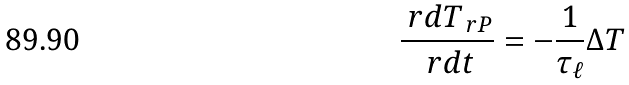<formula> <loc_0><loc_0><loc_500><loc_500>\frac { \ r d T _ { \ r P } } { \ r d t } = - \frac { 1 } { \tau _ { \ell } } \Delta T</formula> 